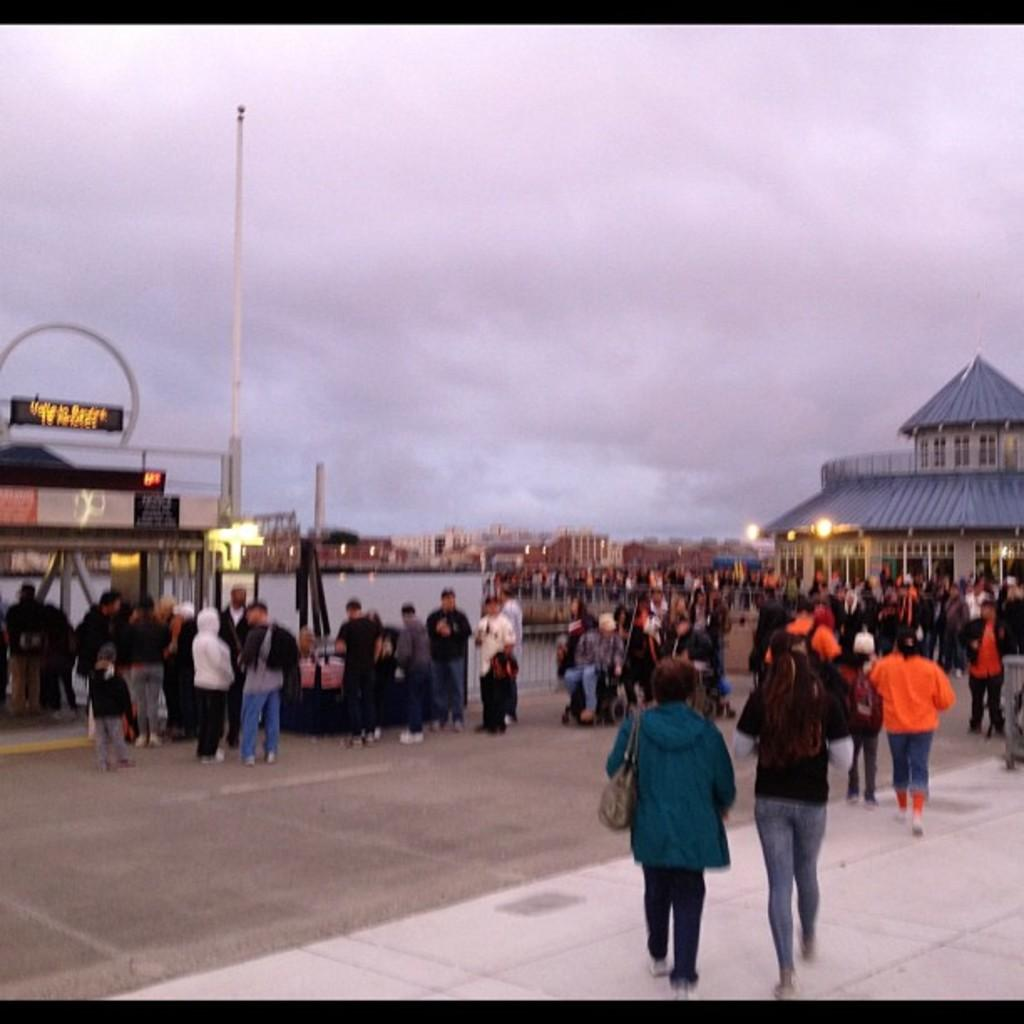What are the people in the foreground of the image doing? The people in the foreground of the image are standing and walking. Where are the people located in relation to the ground? The people are on the ground. What structures can be seen in the image? There are buildings visible in the image. What objects are present in the image that might be used for supporting or guiding? Poles are present in the image. What can be seen illuminating the scene in the image? Lights are visible in the image. What part of the natural environment is visible in the image? The sky is visible in the image. What type of voice can be heard coming from the people in the image? There is no indication of any sound or voice in the image, as it only shows people standing and walking, buildings, poles, lights, and the sky. 